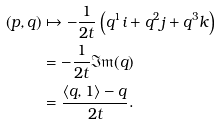<formula> <loc_0><loc_0><loc_500><loc_500>\left ( p , q \right ) & \mapsto - \frac { 1 } { 2 t } \left ( q ^ { 1 } i + q ^ { 2 } j + q ^ { 3 } k \right ) \\ & = - \frac { 1 } { 2 t } \mathfrak { I m } ( q ) \\ & = \frac { \left < q , 1 \right > - q } { 2 t } .</formula> 